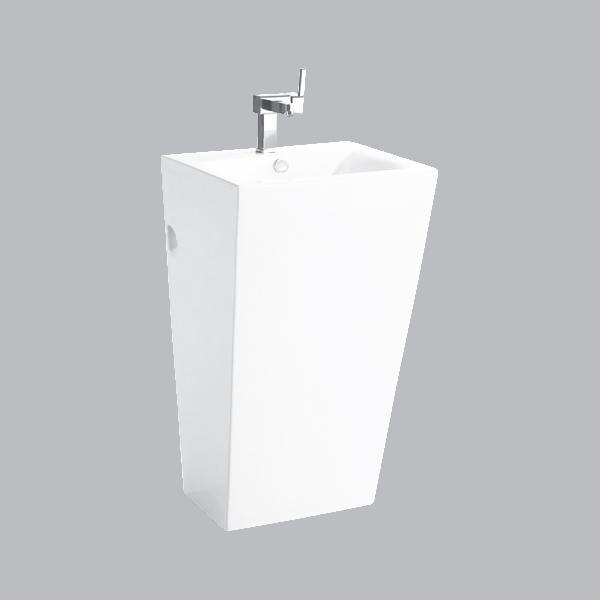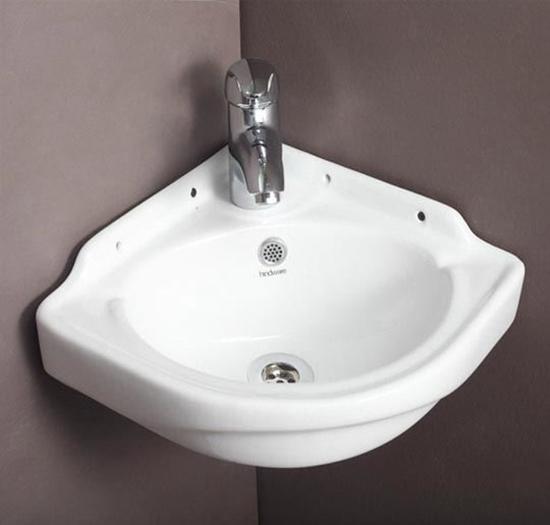The first image is the image on the left, the second image is the image on the right. Analyze the images presented: Is the assertion "One image shows a rectangular, nonpedestal sink with an integrated flat counter." valid? Answer yes or no. No. The first image is the image on the left, the second image is the image on the right. Considering the images on both sides, is "One image shows a rectangular, nonpedestal sink with an integrated flat counter." valid? Answer yes or no. No. 